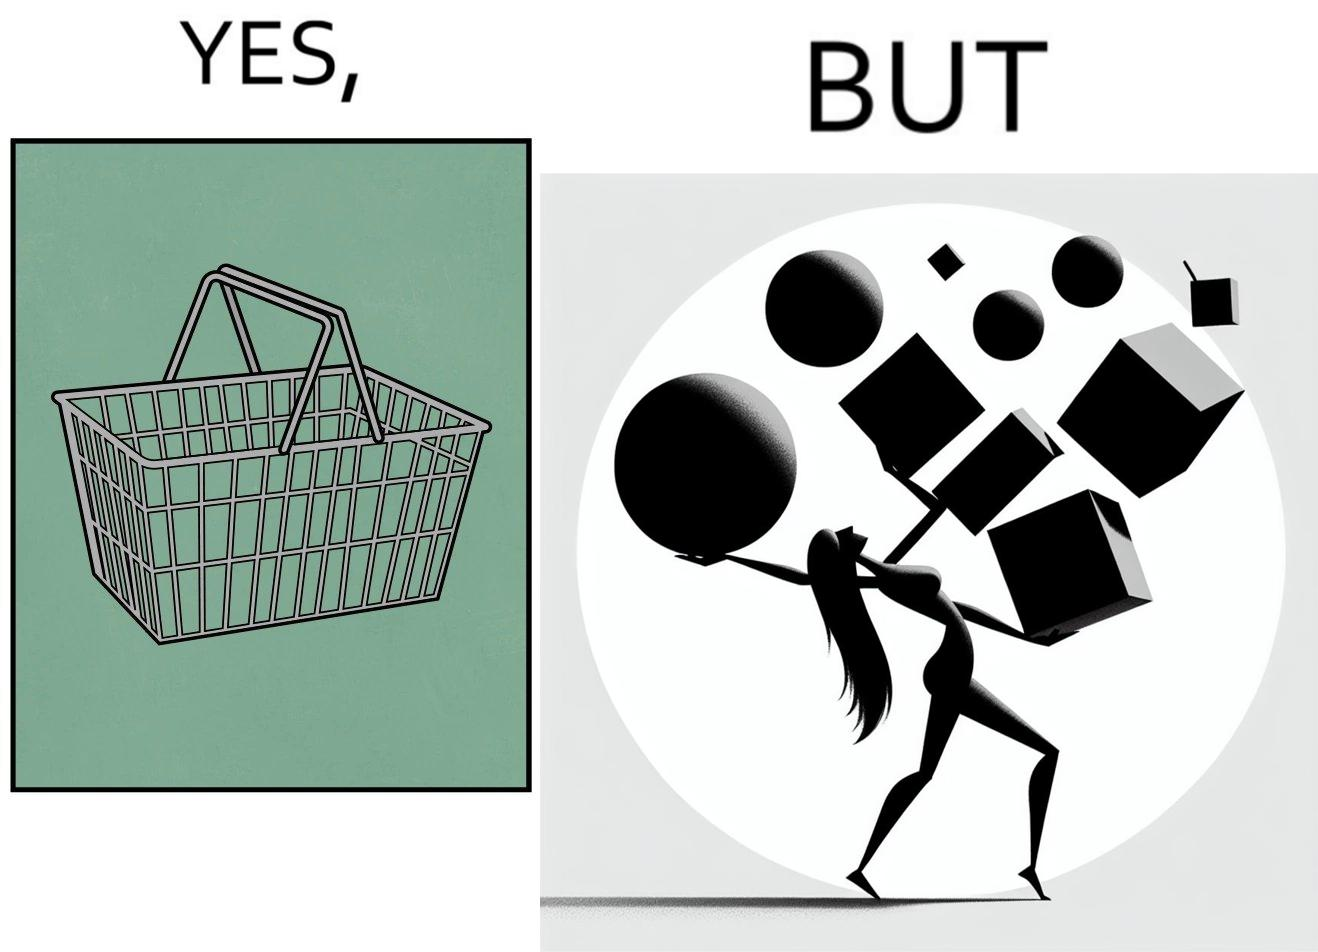Describe what you see in the left and right parts of this image. In the left part of the image: a steel frame basket In the right part of the image: a woman carrying many objects at once trying to hold them, and protecting them from falling off 